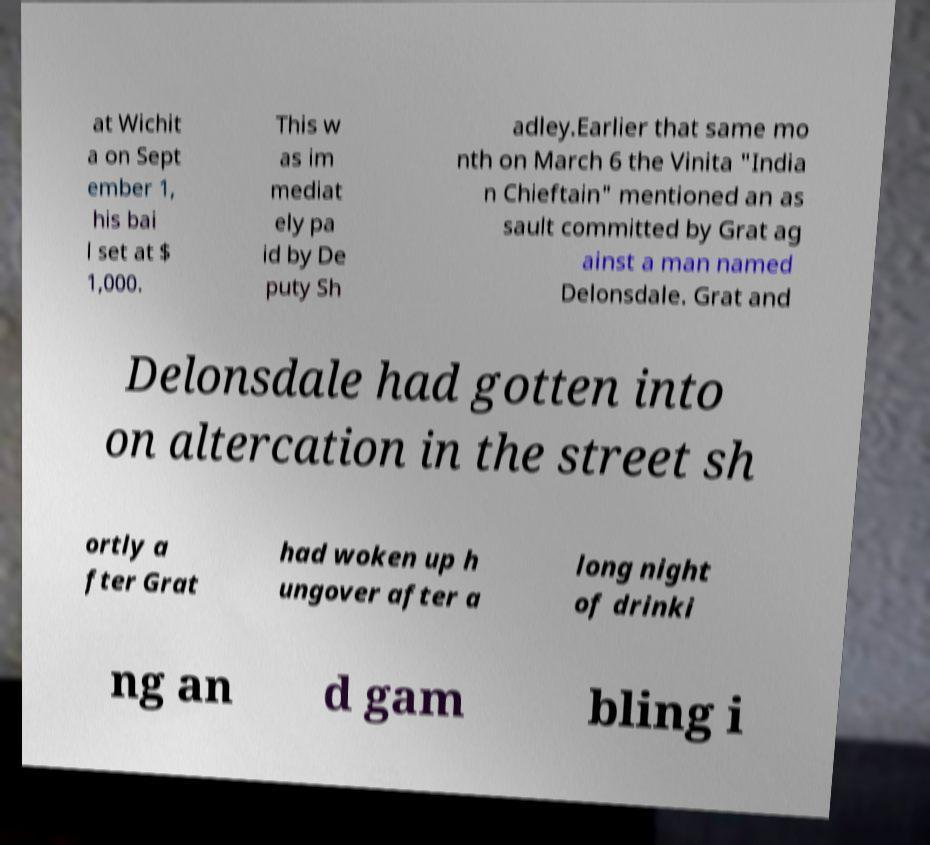Can you read and provide the text displayed in the image?This photo seems to have some interesting text. Can you extract and type it out for me? at Wichit a on Sept ember 1, his bai l set at $ 1,000. This w as im mediat ely pa id by De puty Sh adley.Earlier that same mo nth on March 6 the Vinita "India n Chieftain" mentioned an as sault committed by Grat ag ainst a man named Delonsdale. Grat and Delonsdale had gotten into on altercation in the street sh ortly a fter Grat had woken up h ungover after a long night of drinki ng an d gam bling i 